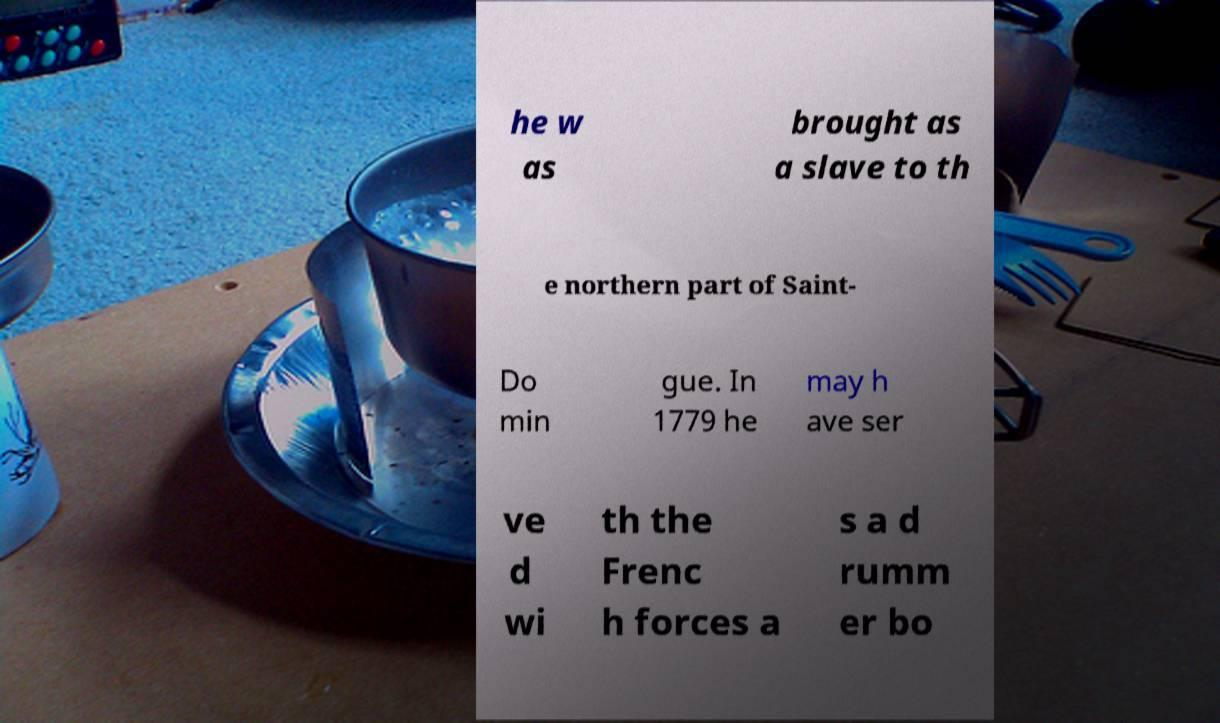What messages or text are displayed in this image? I need them in a readable, typed format. he w as brought as a slave to th e northern part of Saint- Do min gue. In 1779 he may h ave ser ve d wi th the Frenc h forces a s a d rumm er bo 